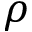Convert formula to latex. <formula><loc_0><loc_0><loc_500><loc_500>\rho</formula> 